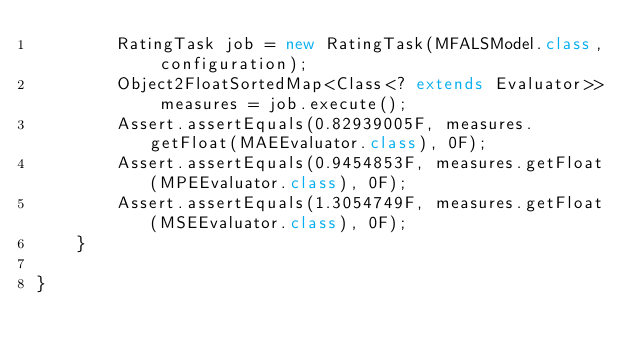Convert code to text. <code><loc_0><loc_0><loc_500><loc_500><_Java_>        RatingTask job = new RatingTask(MFALSModel.class, configuration);
        Object2FloatSortedMap<Class<? extends Evaluator>> measures = job.execute();
        Assert.assertEquals(0.82939005F, measures.getFloat(MAEEvaluator.class), 0F);
        Assert.assertEquals(0.9454853F, measures.getFloat(MPEEvaluator.class), 0F);
        Assert.assertEquals(1.3054749F, measures.getFloat(MSEEvaluator.class), 0F);
    }

}
</code> 